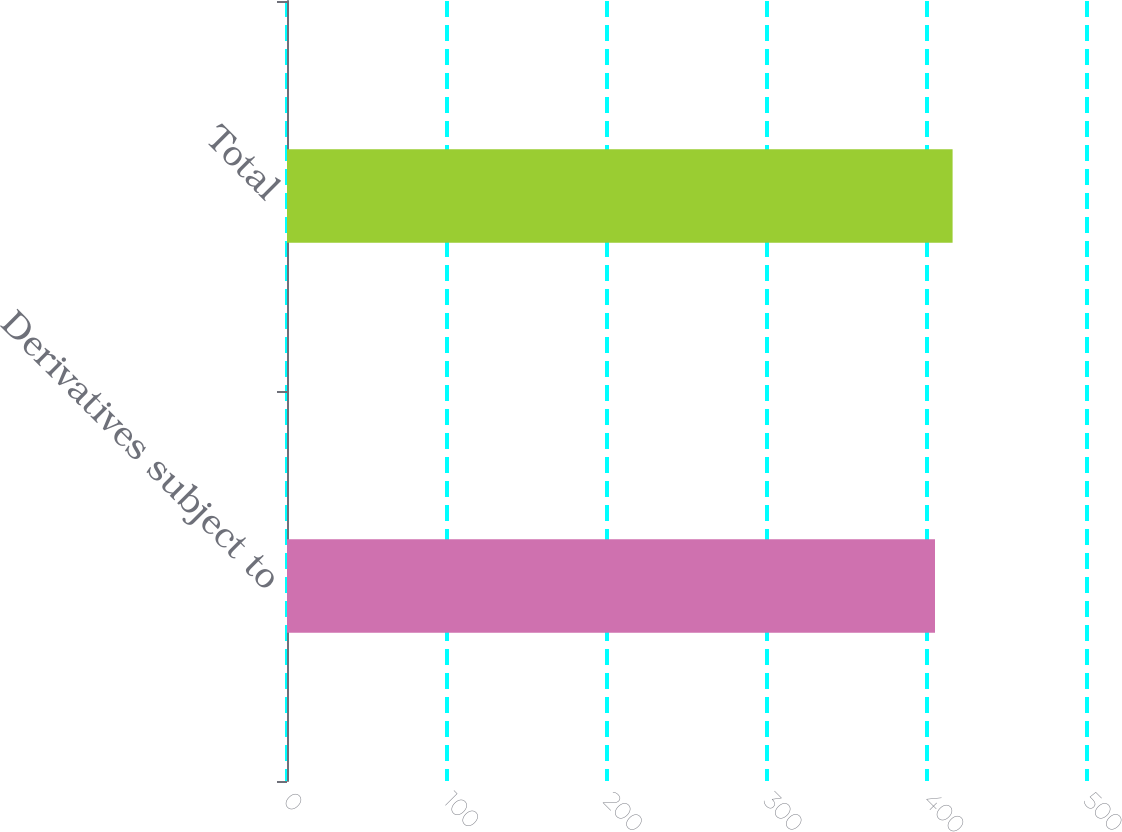<chart> <loc_0><loc_0><loc_500><loc_500><bar_chart><fcel>Derivatives subject to<fcel>Total<nl><fcel>405<fcel>416<nl></chart> 